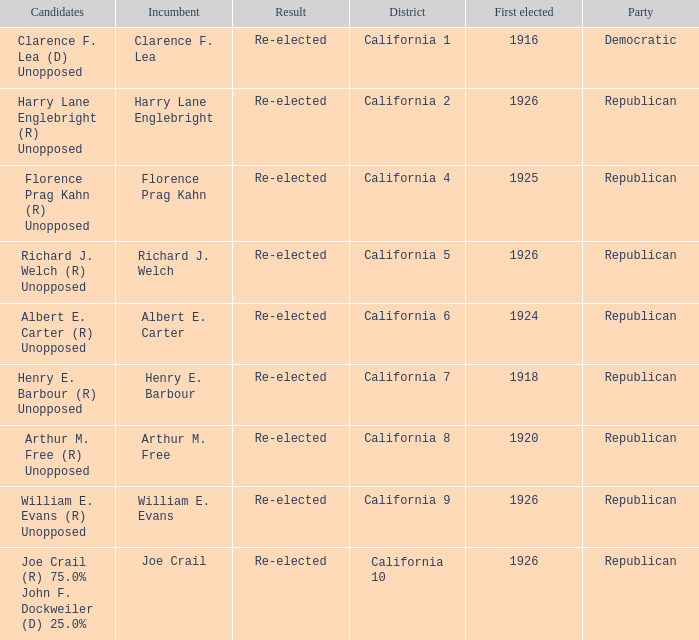What's the party with incumbent being william e. evans Republican. 